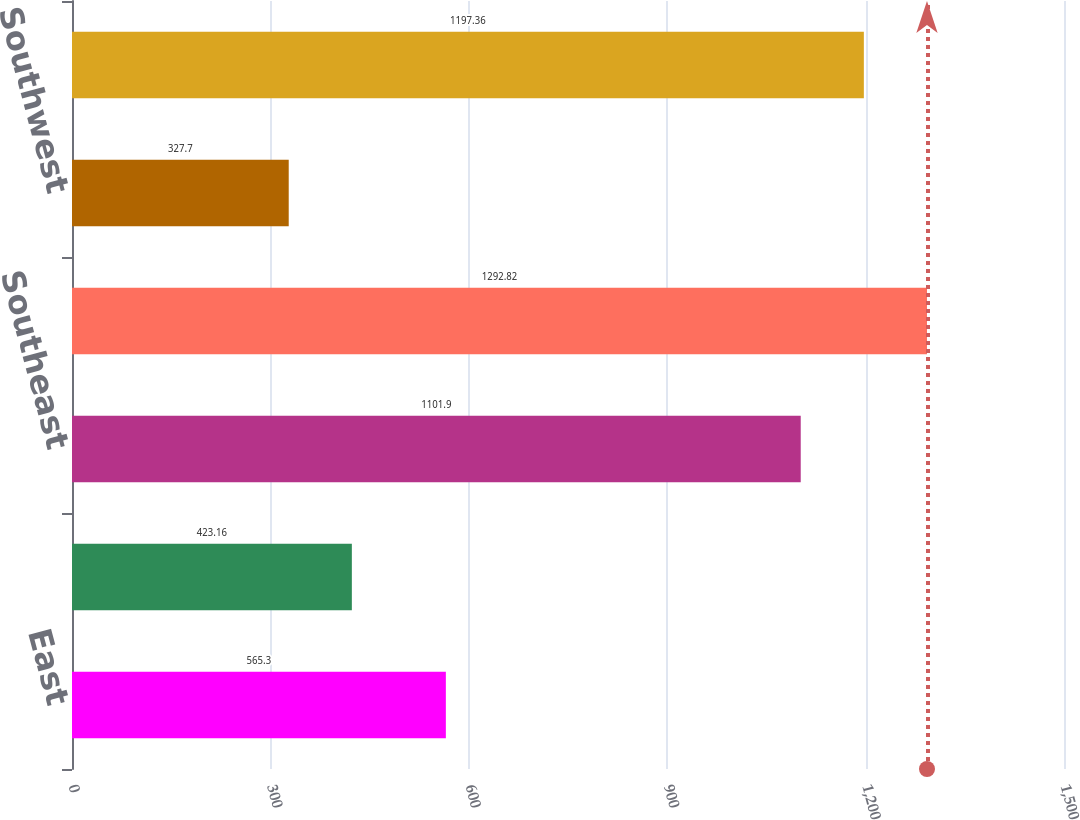Convert chart to OTSL. <chart><loc_0><loc_0><loc_500><loc_500><bar_chart><fcel>East<fcel>Midwest<fcel>Southeast<fcel>South Central<fcel>Southwest<fcel>West<nl><fcel>565.3<fcel>423.16<fcel>1101.9<fcel>1292.82<fcel>327.7<fcel>1197.36<nl></chart> 